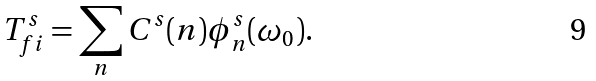<formula> <loc_0><loc_0><loc_500><loc_500>T _ { f i } ^ { s } = \sum _ { n } C ^ { s } ( n ) \phi _ { n } ^ { s } ( \omega _ { 0 } ) .</formula> 